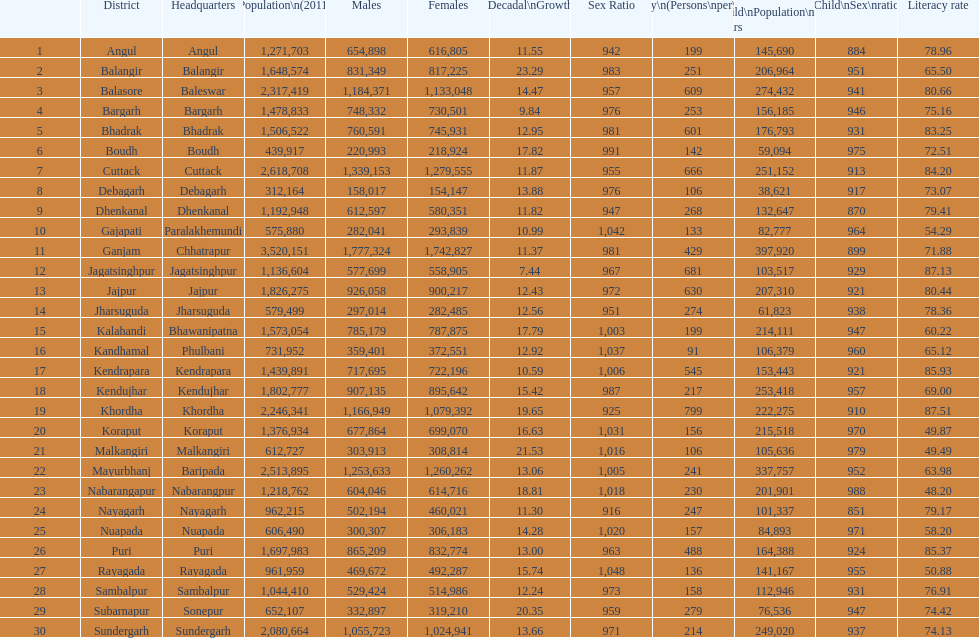Which district has a higher population, angul or cuttack? Cuttack. 